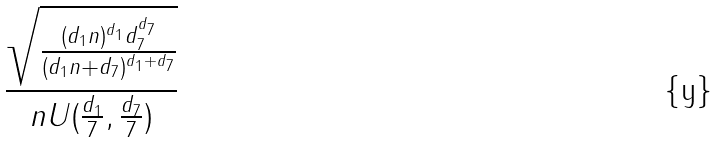Convert formula to latex. <formula><loc_0><loc_0><loc_500><loc_500>\frac { \sqrt { \frac { ( d _ { 1 } n ) ^ { d _ { 1 } } d _ { 7 } ^ { d _ { 7 } } } { ( d _ { 1 } n + d _ { 7 } ) ^ { d _ { 1 } + d _ { 7 } } } } } { n U ( \frac { d _ { 1 } } { 7 } , \frac { d _ { 7 } } { 7 } ) }</formula> 